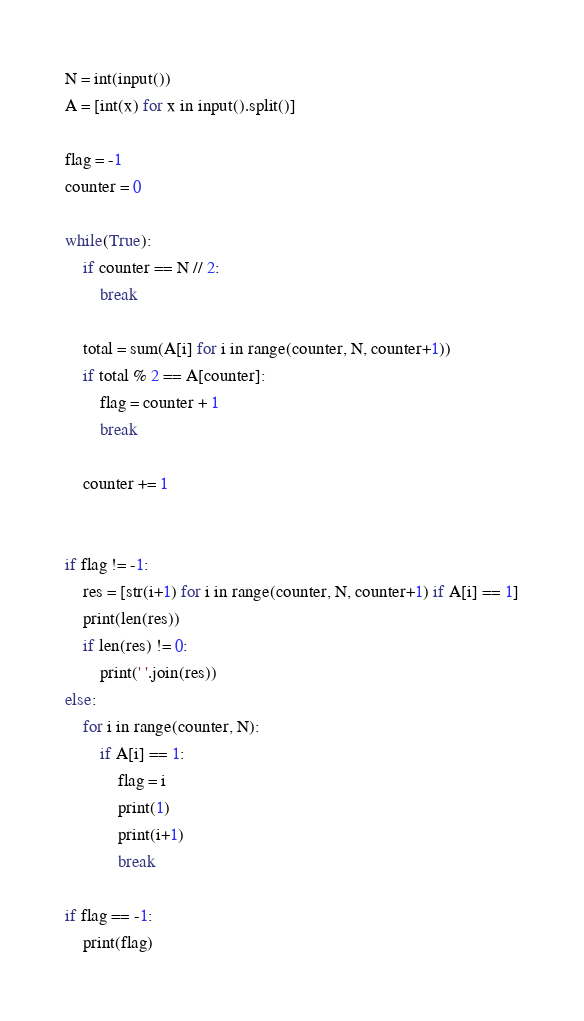Convert code to text. <code><loc_0><loc_0><loc_500><loc_500><_Python_>N = int(input())
A = [int(x) for x in input().split()]

flag = -1
counter = 0

while(True):
    if counter == N // 2:
        break

    total = sum(A[i] for i in range(counter, N, counter+1))
    if total % 2 == A[counter]:
        flag = counter + 1
        break
    
    counter += 1


if flag != -1:
    res = [str(i+1) for i in range(counter, N, counter+1) if A[i] == 1]
    print(len(res))
    if len(res) != 0:
        print(' '.join(res))
else:
    for i in range(counter, N):
        if A[i] == 1:
            flag = i
            print(1)
            print(i+1)
            break

if flag == -1:
    print(flag)</code> 